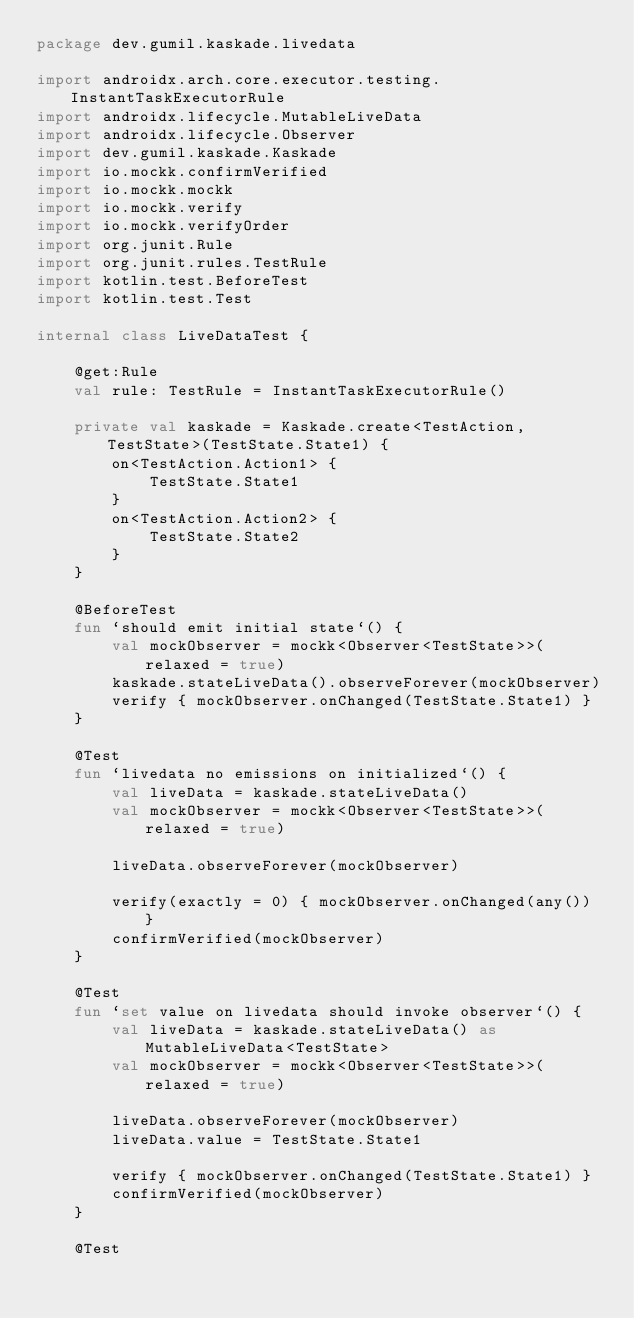<code> <loc_0><loc_0><loc_500><loc_500><_Kotlin_>package dev.gumil.kaskade.livedata

import androidx.arch.core.executor.testing.InstantTaskExecutorRule
import androidx.lifecycle.MutableLiveData
import androidx.lifecycle.Observer
import dev.gumil.kaskade.Kaskade
import io.mockk.confirmVerified
import io.mockk.mockk
import io.mockk.verify
import io.mockk.verifyOrder
import org.junit.Rule
import org.junit.rules.TestRule
import kotlin.test.BeforeTest
import kotlin.test.Test

internal class LiveDataTest {

    @get:Rule
    val rule: TestRule = InstantTaskExecutorRule()

    private val kaskade = Kaskade.create<TestAction, TestState>(TestState.State1) {
        on<TestAction.Action1> {
            TestState.State1
        }
        on<TestAction.Action2> {
            TestState.State2
        }
    }

    @BeforeTest
    fun `should emit initial state`() {
        val mockObserver = mockk<Observer<TestState>>(relaxed = true)
        kaskade.stateLiveData().observeForever(mockObserver)
        verify { mockObserver.onChanged(TestState.State1) }
    }

    @Test
    fun `livedata no emissions on initialized`() {
        val liveData = kaskade.stateLiveData()
        val mockObserver = mockk<Observer<TestState>>(relaxed = true)

        liveData.observeForever(mockObserver)

        verify(exactly = 0) { mockObserver.onChanged(any()) }
        confirmVerified(mockObserver)
    }

    @Test
    fun `set value on livedata should invoke observer`() {
        val liveData = kaskade.stateLiveData() as MutableLiveData<TestState>
        val mockObserver = mockk<Observer<TestState>>(relaxed = true)

        liveData.observeForever(mockObserver)
        liveData.value = TestState.State1

        verify { mockObserver.onChanged(TestState.State1) }
        confirmVerified(mockObserver)
    }

    @Test</code> 